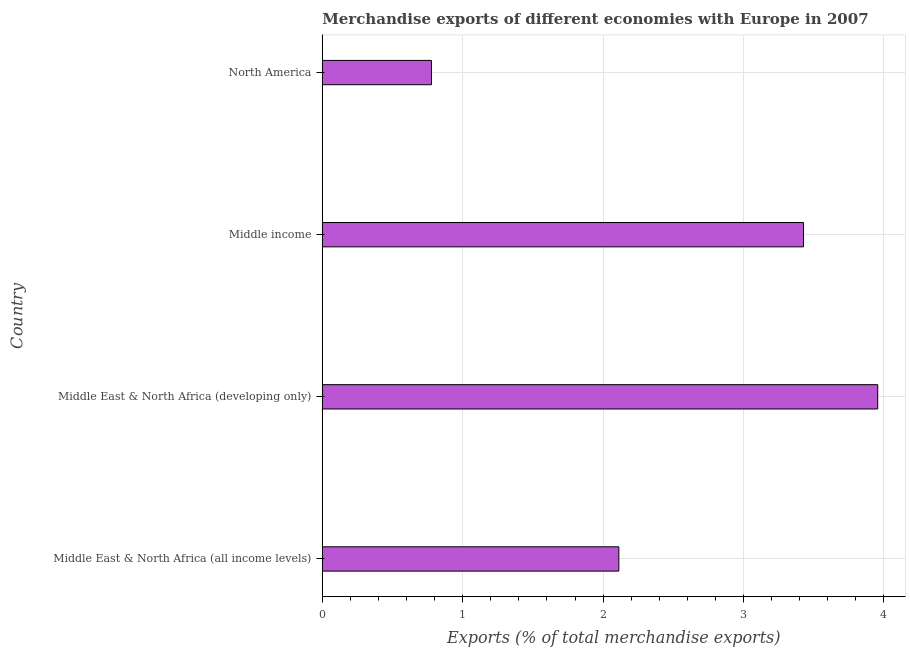Does the graph contain any zero values?
Provide a succinct answer. No. Does the graph contain grids?
Make the answer very short. Yes. What is the title of the graph?
Your answer should be very brief. Merchandise exports of different economies with Europe in 2007. What is the label or title of the X-axis?
Provide a succinct answer. Exports (% of total merchandise exports). What is the merchandise exports in Middle East & North Africa (developing only)?
Give a very brief answer. 3.96. Across all countries, what is the maximum merchandise exports?
Offer a terse response. 3.96. Across all countries, what is the minimum merchandise exports?
Your answer should be compact. 0.78. In which country was the merchandise exports maximum?
Keep it short and to the point. Middle East & North Africa (developing only). In which country was the merchandise exports minimum?
Make the answer very short. North America. What is the sum of the merchandise exports?
Your response must be concise. 10.27. What is the difference between the merchandise exports in Middle East & North Africa (all income levels) and North America?
Keep it short and to the point. 1.33. What is the average merchandise exports per country?
Make the answer very short. 2.57. What is the median merchandise exports?
Provide a succinct answer. 2.77. What is the ratio of the merchandise exports in Middle East & North Africa (all income levels) to that in North America?
Offer a very short reply. 2.72. What is the difference between the highest and the second highest merchandise exports?
Offer a terse response. 0.53. What is the difference between the highest and the lowest merchandise exports?
Ensure brevity in your answer.  3.18. Are all the bars in the graph horizontal?
Provide a short and direct response. Yes. How many countries are there in the graph?
Provide a short and direct response. 4. What is the difference between two consecutive major ticks on the X-axis?
Your answer should be very brief. 1. What is the Exports (% of total merchandise exports) of Middle East & North Africa (all income levels)?
Offer a very short reply. 2.11. What is the Exports (% of total merchandise exports) of Middle East & North Africa (developing only)?
Your answer should be very brief. 3.96. What is the Exports (% of total merchandise exports) of Middle income?
Your answer should be very brief. 3.43. What is the Exports (% of total merchandise exports) of North America?
Keep it short and to the point. 0.78. What is the difference between the Exports (% of total merchandise exports) in Middle East & North Africa (all income levels) and Middle East & North Africa (developing only)?
Offer a very short reply. -1.84. What is the difference between the Exports (% of total merchandise exports) in Middle East & North Africa (all income levels) and Middle income?
Your response must be concise. -1.32. What is the difference between the Exports (% of total merchandise exports) in Middle East & North Africa (all income levels) and North America?
Ensure brevity in your answer.  1.33. What is the difference between the Exports (% of total merchandise exports) in Middle East & North Africa (developing only) and Middle income?
Ensure brevity in your answer.  0.53. What is the difference between the Exports (% of total merchandise exports) in Middle East & North Africa (developing only) and North America?
Your response must be concise. 3.18. What is the difference between the Exports (% of total merchandise exports) in Middle income and North America?
Your answer should be compact. 2.65. What is the ratio of the Exports (% of total merchandise exports) in Middle East & North Africa (all income levels) to that in Middle East & North Africa (developing only)?
Your answer should be compact. 0.53. What is the ratio of the Exports (% of total merchandise exports) in Middle East & North Africa (all income levels) to that in Middle income?
Give a very brief answer. 0.62. What is the ratio of the Exports (% of total merchandise exports) in Middle East & North Africa (all income levels) to that in North America?
Your response must be concise. 2.72. What is the ratio of the Exports (% of total merchandise exports) in Middle East & North Africa (developing only) to that in Middle income?
Keep it short and to the point. 1.15. What is the ratio of the Exports (% of total merchandise exports) in Middle East & North Africa (developing only) to that in North America?
Provide a succinct answer. 5.09. What is the ratio of the Exports (% of total merchandise exports) in Middle income to that in North America?
Offer a terse response. 4.41. 